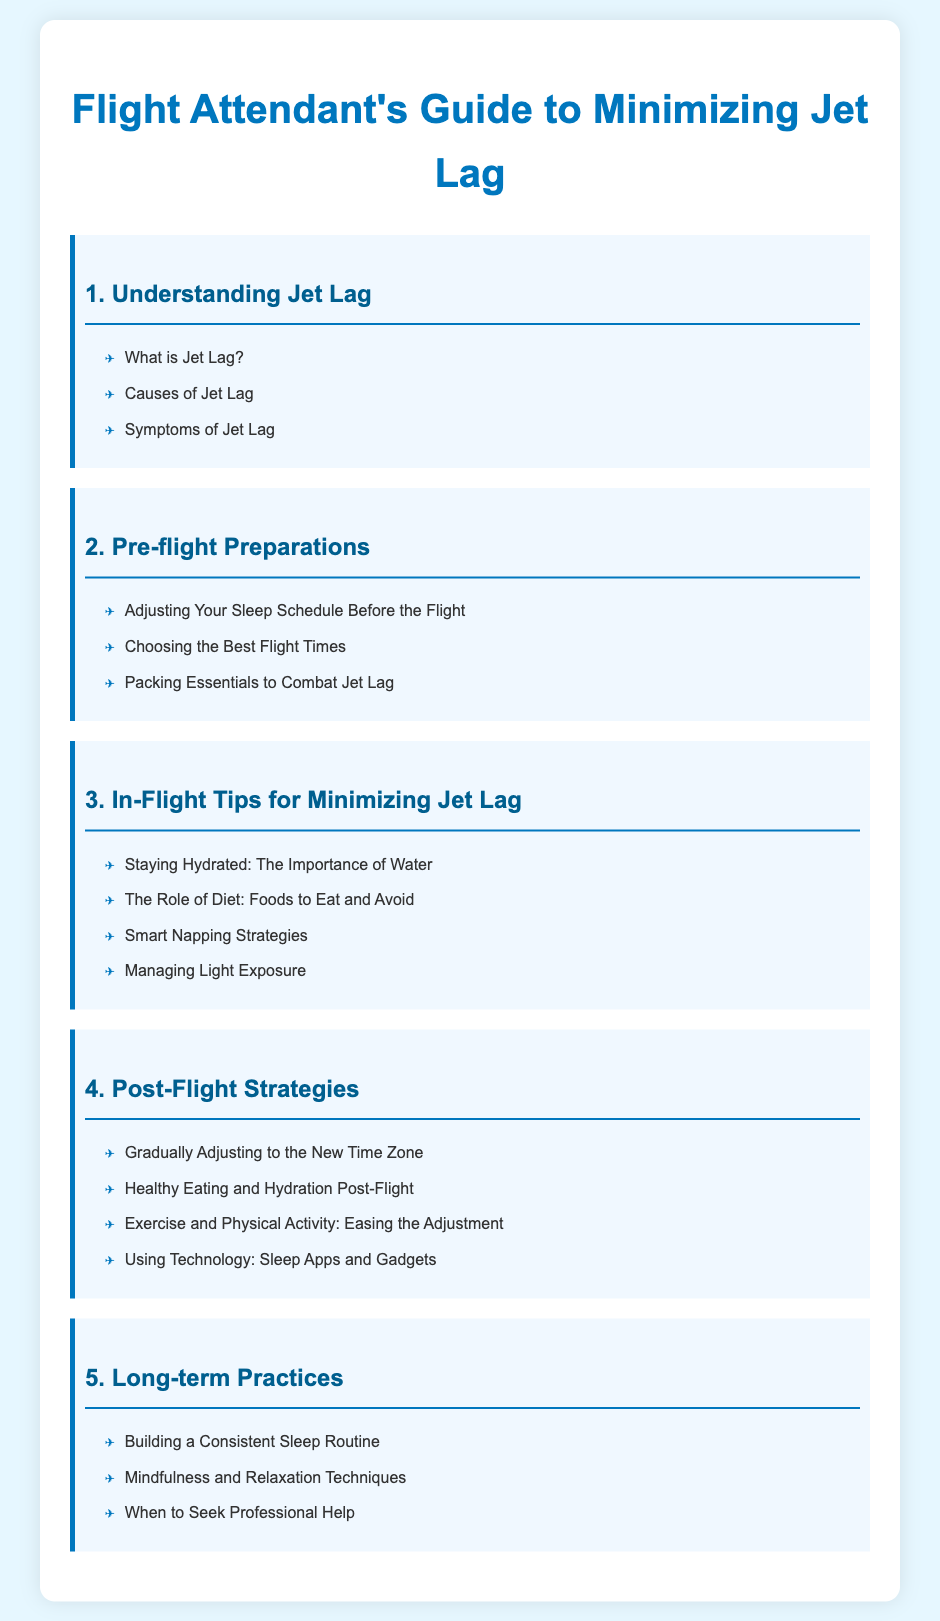What is the first chapter? The first chapter is titled "Understanding Jet Lag".
Answer: Understanding Jet Lag How many subtopics are in the third chapter? The third chapter has four subtopics listed under it.
Answer: 4 What should you avoid eating on a flight? The third chapter includes a subtopic about "Foods to Eat and Avoid".
Answer: Foods to Eat and Avoid Which chapter discusses post-flight strategies? The fourth chapter is dedicated to post-flight strategies.
Answer: 4 What technique is suggested for easing adjustment to a new time zone? "Exercise and Physical Activity: Easing the Adjustment" is mentioned in the fourth chapter.
Answer: Exercise and Physical Activity What is suggested as a long-term practice for sleep? "Building a Consistent Sleep Routine" is a suggested long-term practice.
Answer: Building a Consistent Sleep Routine What does the second chapter focus on? The second chapter focuses on pre-flight preparations.
Answer: Pre-flight Preparations How is the document structured? The document is structured as a guide with chapters and subtopics outlined in a table of contents format.
Answer: Table of contents format 